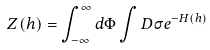Convert formula to latex. <formula><loc_0><loc_0><loc_500><loc_500>Z ( h ) = \int _ { - \infty } ^ { \infty } d \Phi \int D \sigma e ^ { - H ( h ) }</formula> 